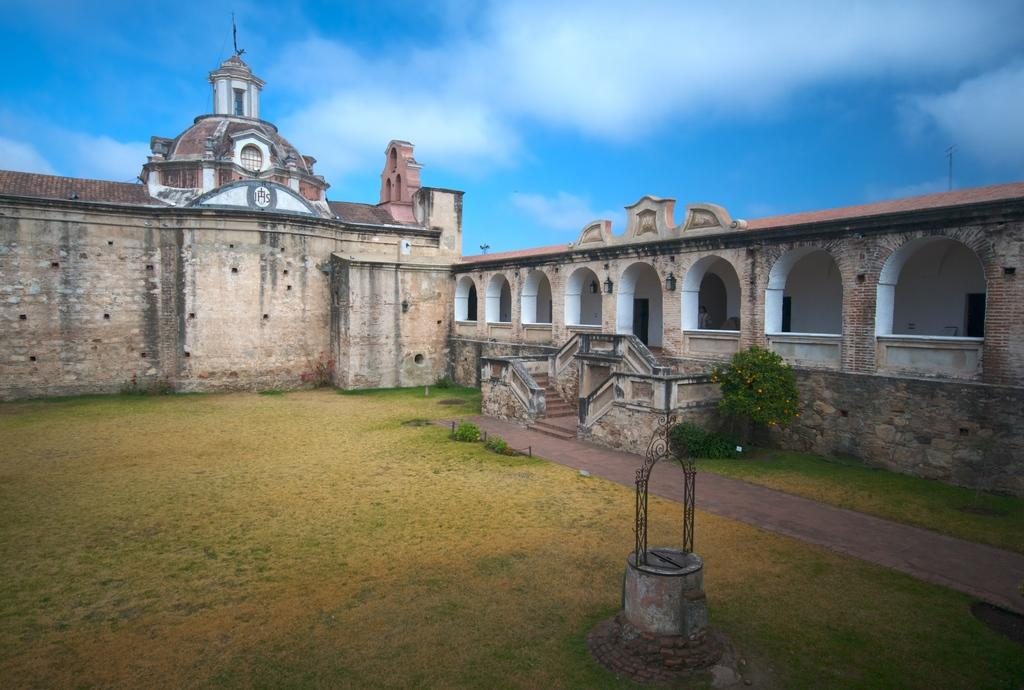What type of living organisms can be seen in the image? Plants can be seen in the image. What architectural feature is present in the image? There are stairs in the image. What type of structure is visible in the image? There is a building in the image. What is your uncle doing in the image? There is no reference to an uncle or any person in the image, so it's not possible to answer that question. 